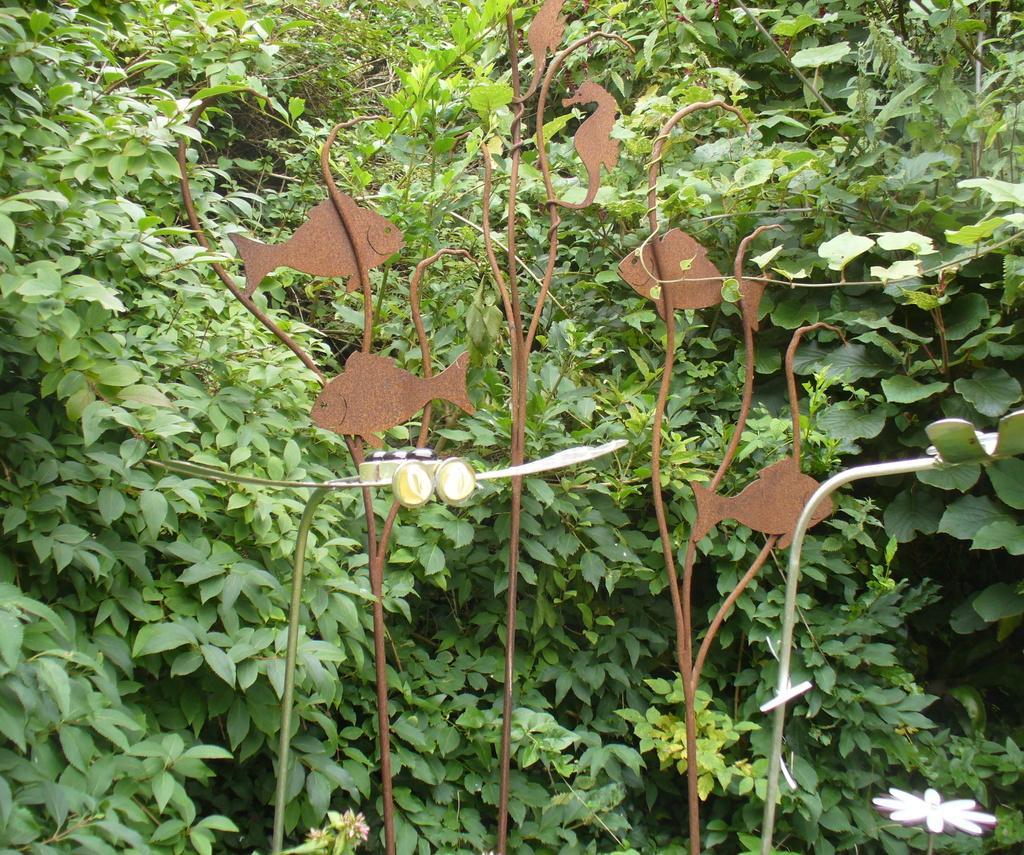How would you summarize this image in a sentence or two? In this picture we can see some fishes and a seahorse on a brown object. There is a white flower on bottom right. Few plants are visible in the background. 